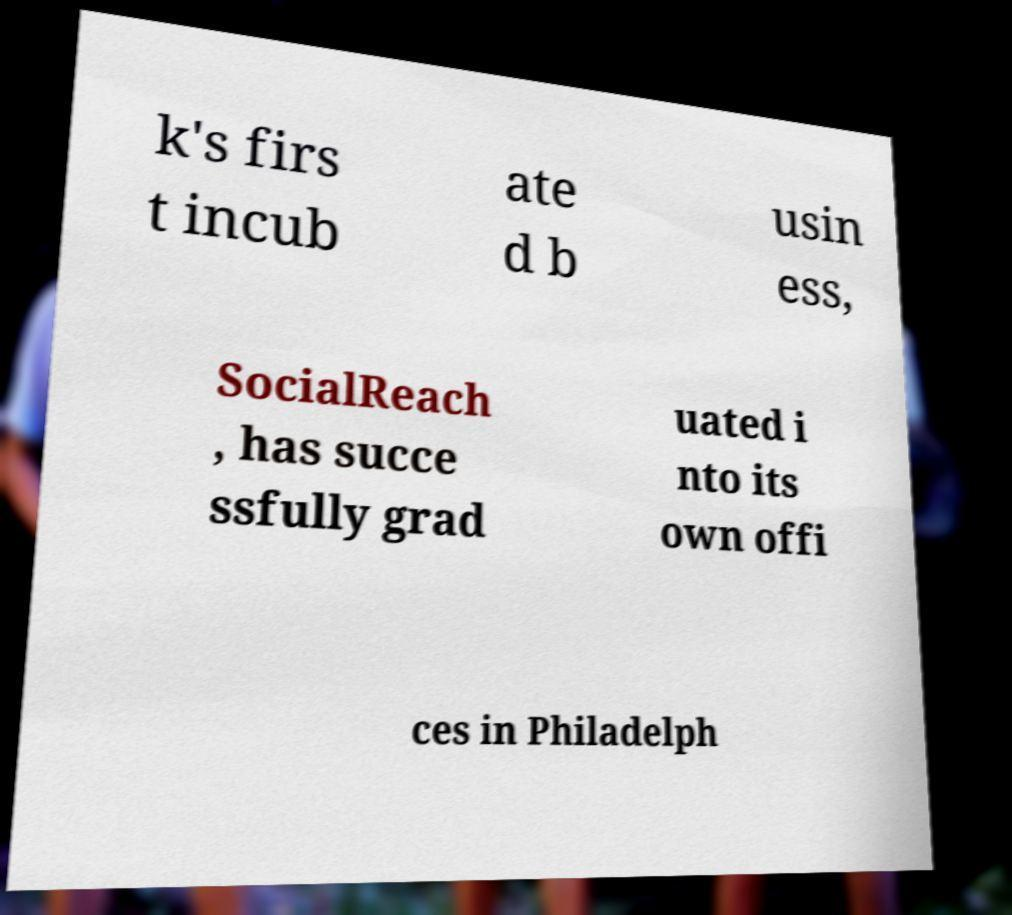Please identify and transcribe the text found in this image. k's firs t incub ate d b usin ess, SocialReach , has succe ssfully grad uated i nto its own offi ces in Philadelph 